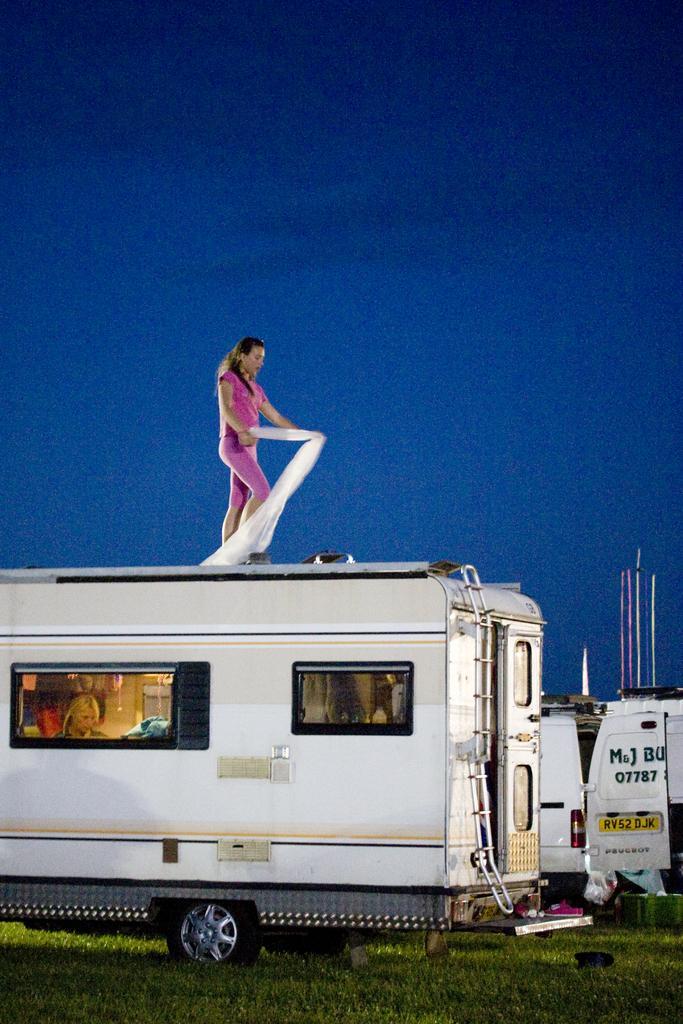How would you summarize this image in a sentence or two? There is a van with windows and ladder. A lady is holding a cloth and standing on the van. Inside the van there is another lady. On the ground there is grass. In the back there is another vehicle with a door. On the door something is written. In the background there is sky. 